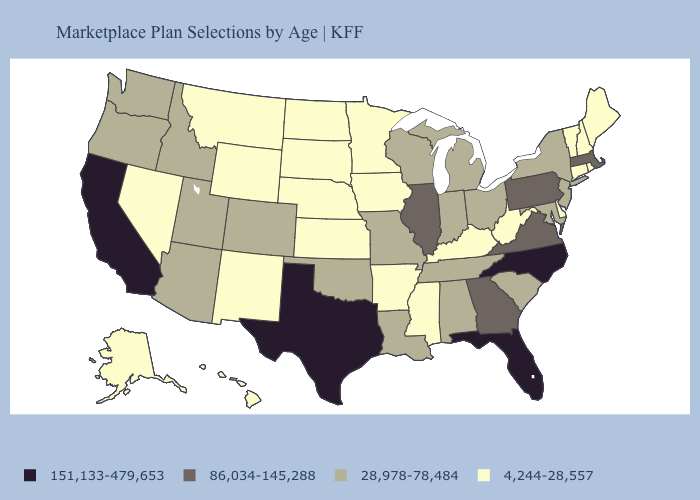Among the states that border Nebraska , does Missouri have the lowest value?
Keep it brief. No. Does Montana have the lowest value in the USA?
Write a very short answer. Yes. Which states have the lowest value in the USA?
Keep it brief. Alaska, Arkansas, Connecticut, Delaware, Hawaii, Iowa, Kansas, Kentucky, Maine, Minnesota, Mississippi, Montana, Nebraska, Nevada, New Hampshire, New Mexico, North Dakota, Rhode Island, South Dakota, Vermont, West Virginia, Wyoming. Which states have the lowest value in the South?
Concise answer only. Arkansas, Delaware, Kentucky, Mississippi, West Virginia. Name the states that have a value in the range 86,034-145,288?
Answer briefly. Georgia, Illinois, Massachusetts, Pennsylvania, Virginia. Does Arizona have the same value as West Virginia?
Keep it brief. No. Does Indiana have a higher value than Virginia?
Write a very short answer. No. Does the map have missing data?
Be succinct. No. What is the highest value in states that border New Jersey?
Concise answer only. 86,034-145,288. Name the states that have a value in the range 28,978-78,484?
Quick response, please. Alabama, Arizona, Colorado, Idaho, Indiana, Louisiana, Maryland, Michigan, Missouri, New Jersey, New York, Ohio, Oklahoma, Oregon, South Carolina, Tennessee, Utah, Washington, Wisconsin. Does Texas have the highest value in the South?
Give a very brief answer. Yes. What is the highest value in states that border Oklahoma?
Answer briefly. 151,133-479,653. Does Texas have a lower value than Louisiana?
Quick response, please. No. What is the value of Arizona?
Give a very brief answer. 28,978-78,484. Which states hav the highest value in the Northeast?
Keep it brief. Massachusetts, Pennsylvania. 